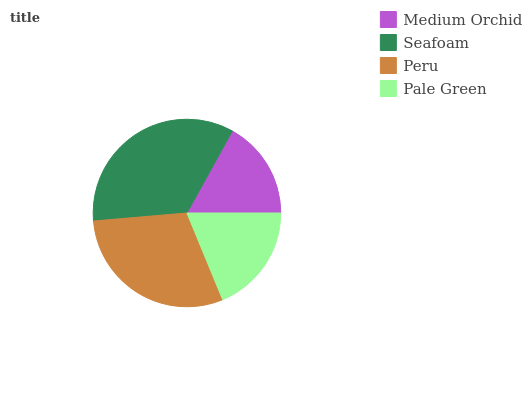Is Medium Orchid the minimum?
Answer yes or no. Yes. Is Seafoam the maximum?
Answer yes or no. Yes. Is Peru the minimum?
Answer yes or no. No. Is Peru the maximum?
Answer yes or no. No. Is Seafoam greater than Peru?
Answer yes or no. Yes. Is Peru less than Seafoam?
Answer yes or no. Yes. Is Peru greater than Seafoam?
Answer yes or no. No. Is Seafoam less than Peru?
Answer yes or no. No. Is Peru the high median?
Answer yes or no. Yes. Is Pale Green the low median?
Answer yes or no. Yes. Is Seafoam the high median?
Answer yes or no. No. Is Medium Orchid the low median?
Answer yes or no. No. 